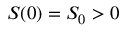<formula> <loc_0><loc_0><loc_500><loc_500>S ( 0 ) = S _ { 0 } > 0</formula> 